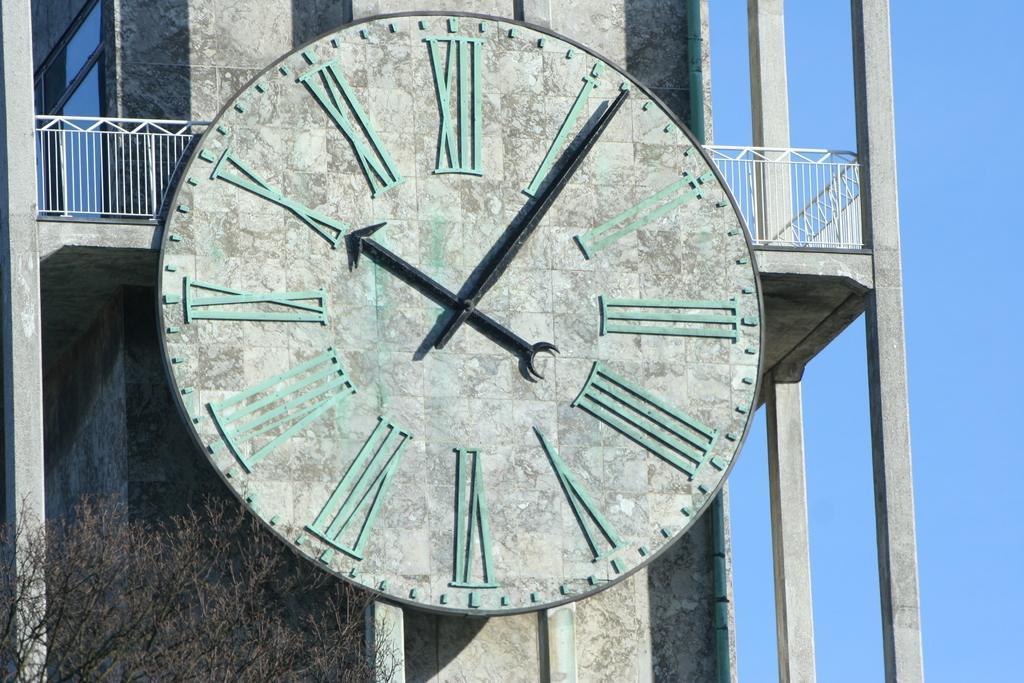Could you give a brief overview of what you see in this image? In the image we can see there is a clock on the building and there is a tree. 